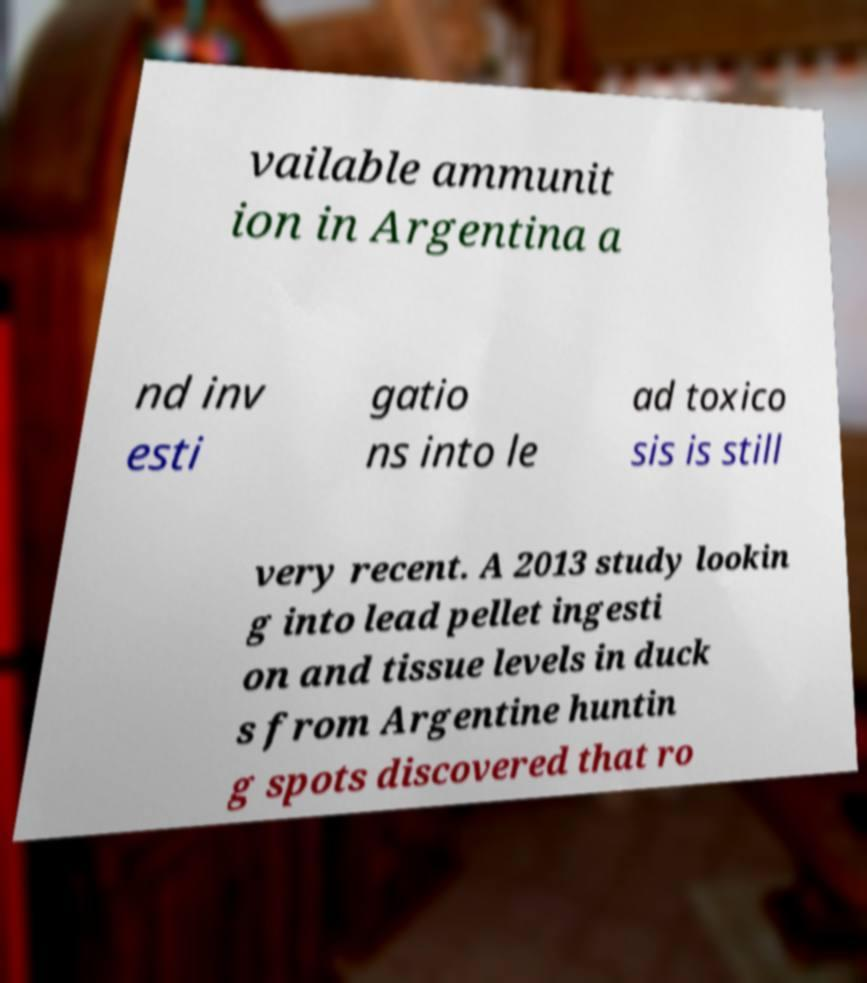Please identify and transcribe the text found in this image. vailable ammunit ion in Argentina a nd inv esti gatio ns into le ad toxico sis is still very recent. A 2013 study lookin g into lead pellet ingesti on and tissue levels in duck s from Argentine huntin g spots discovered that ro 